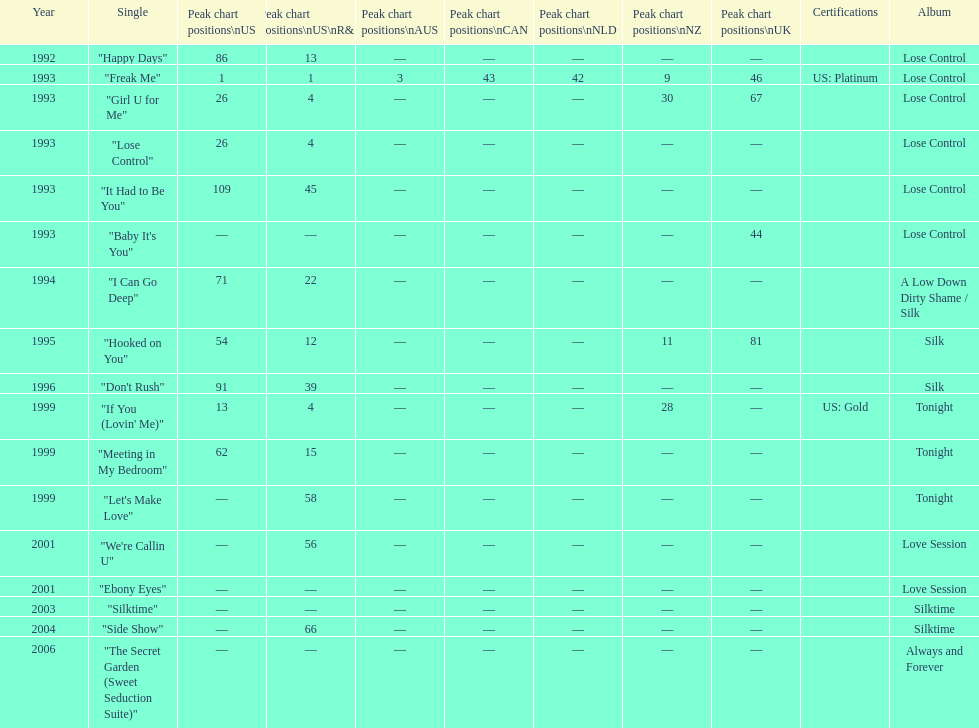Which sole track holds the record for the most times it appeared on the charts? "Freak Me". 